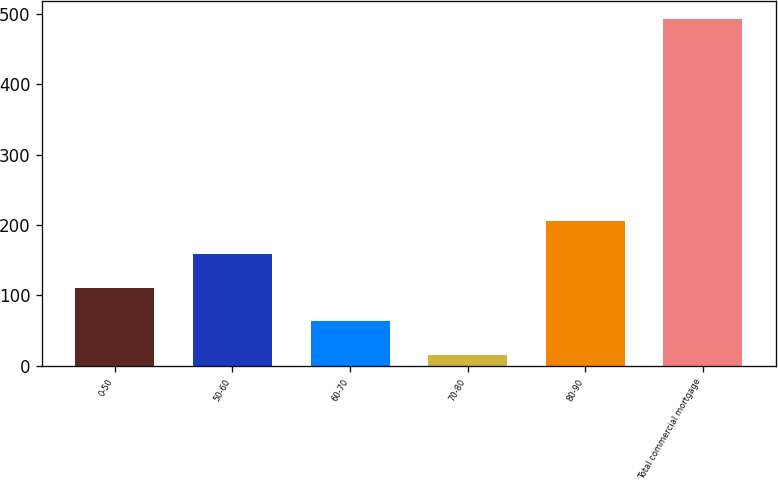Convert chart. <chart><loc_0><loc_0><loc_500><loc_500><bar_chart><fcel>0-50<fcel>50-60<fcel>60-70<fcel>70-80<fcel>80-90<fcel>Total commercial mortgage<nl><fcel>110.6<fcel>158.4<fcel>62.8<fcel>15<fcel>206.2<fcel>493<nl></chart> 